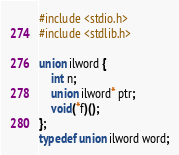Convert code to text. <code><loc_0><loc_0><loc_500><loc_500><_C_>#include <stdio.h>
#include <stdlib.h>

union ilword {
    int n;
    union ilword* ptr;
    void(*f)();
};
typedef union ilword word;
</code> 